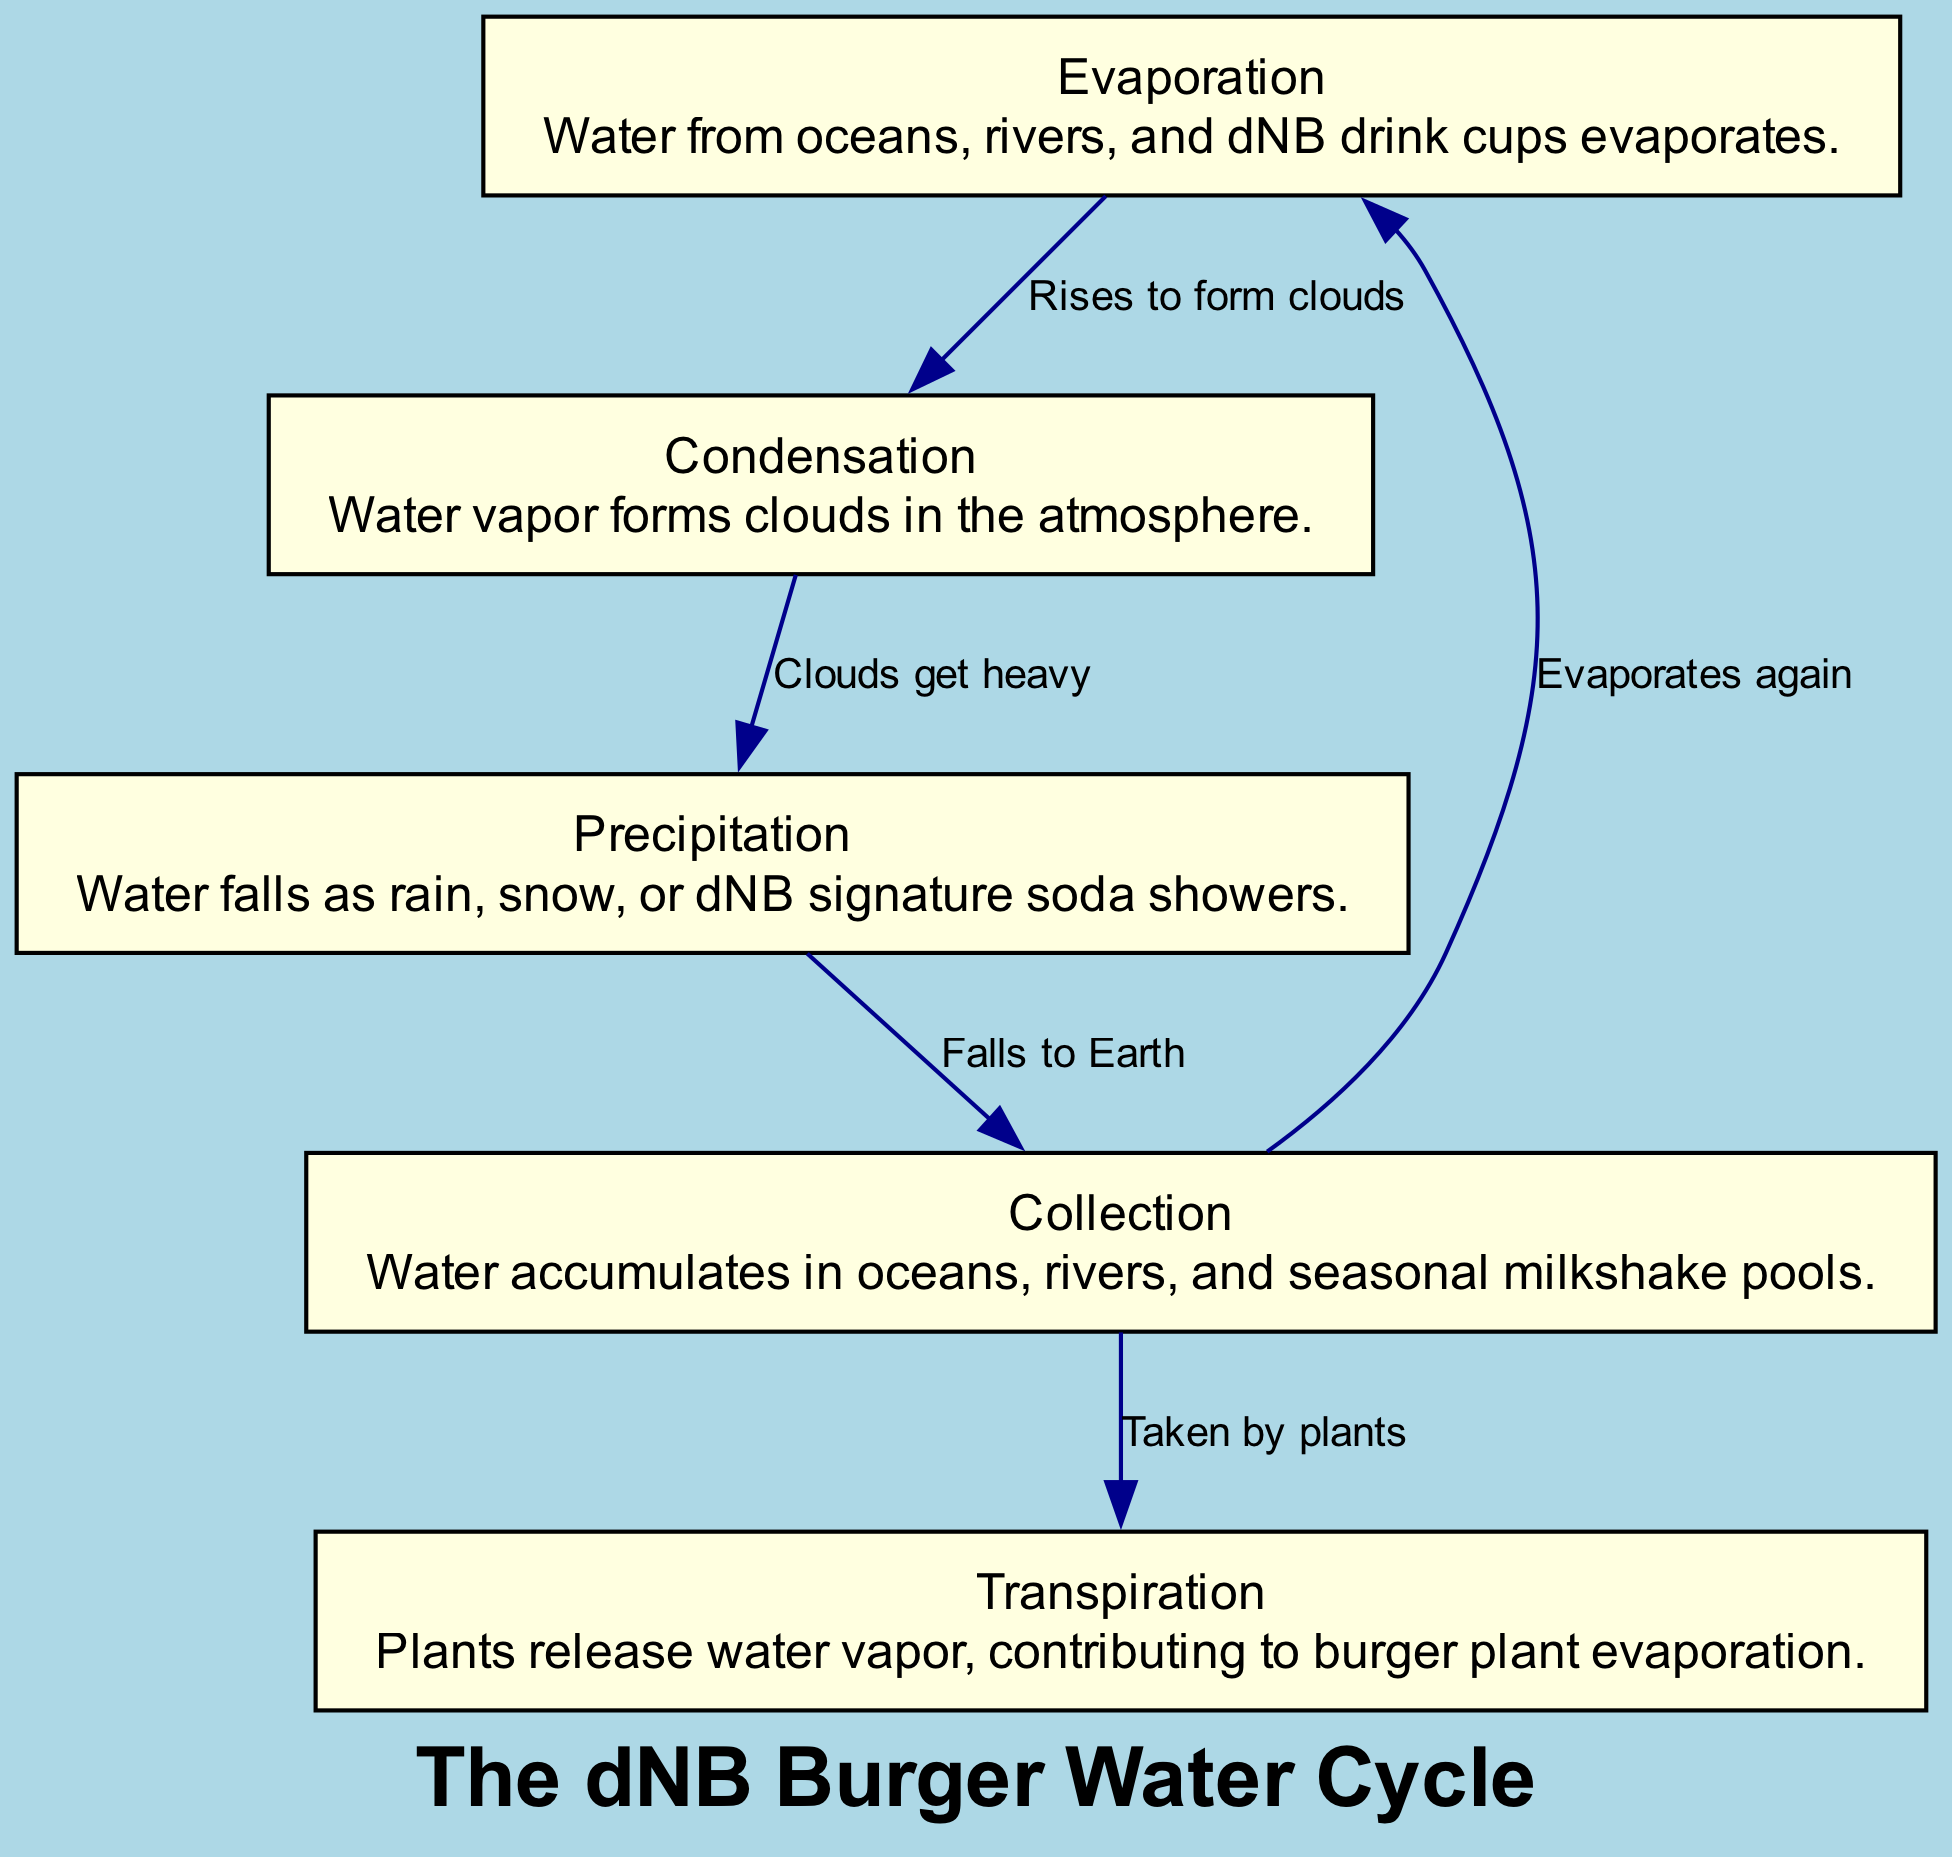What is the first step in the water cycle? The diagram starts with the node labeled "Evaporation," indicating that the first step is that water evaporates from sources like oceans and rivers.
Answer: Evaporation How many nodes are represented in the diagram? The diagram includes five nodes: Evaporation, Condensation, Precipitation, Collection, and Transpiration. Thus, the total count is five.
Answer: 5 What happens to water after it forms clouds? According to the diagram, after condensation (cloud formation), the next step is that clouds become heavy, leading to precipitation.
Answer: Precipitation Which process is triggered by plants? The "Transpiration" node in the diagram shows that plants release water vapor, contributing to the water cycle.
Answer: Transpiration What is the relationship between Collection and Evaporation? The diagram indicates that water collected in oceans and rivers will eventually evaporate again, forming a loop in the cycle.
Answer: Evaporates again What do clouds do when they get heavy? The diagram illustrates that heavy clouds lead to precipitation, resulting in water falling as rain or snow.
Answer: Falls to Earth Which two processes directly contribute to the formation of water vapor in the atmosphere? The diagram shows that both Evaporation (from water sources) and Transpiration (from plants) contribute to forming water vapor.
Answer: Evaporation and Transpiration What is the endpoint of the precipitation process? The diagram indicates that the endpoint of precipitation is the Collection node, where water accumulates back into bodies of water.
Answer: Collection What additional sources are indicated in the descriptions aside from natural water sources? The diagram mentions dNB drink cups and dNB signature soda showers as additional sources of water contributing to evaporation and precipitation.
Answer: dNB drink cups and dNB signature soda showers 